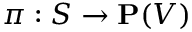<formula> <loc_0><loc_0><loc_500><loc_500>\pi \colon S \to P ( V )</formula> 